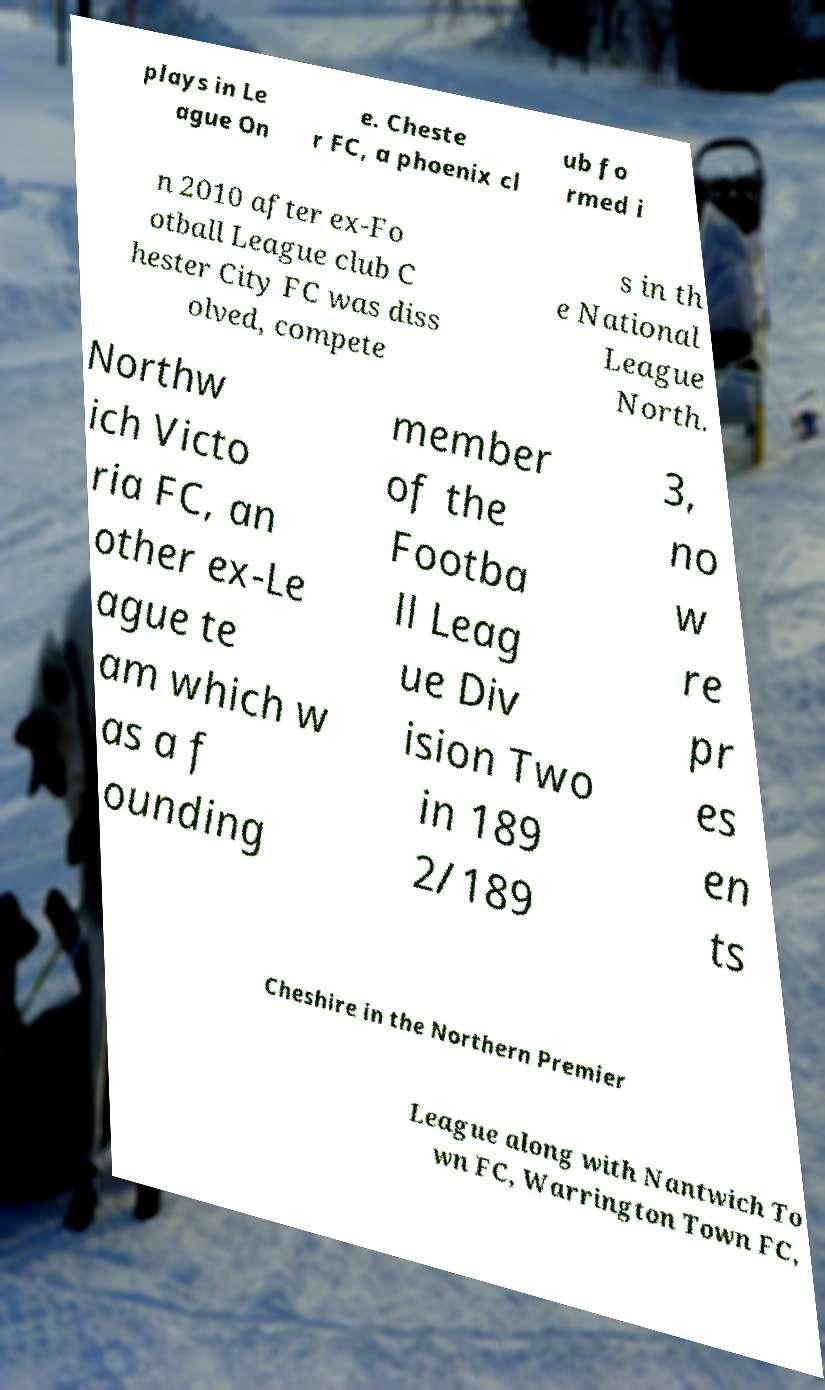For documentation purposes, I need the text within this image transcribed. Could you provide that? plays in Le ague On e. Cheste r FC, a phoenix cl ub fo rmed i n 2010 after ex-Fo otball League club C hester City FC was diss olved, compete s in th e National League North. Northw ich Victo ria FC, an other ex-Le ague te am which w as a f ounding member of the Footba ll Leag ue Div ision Two in 189 2/189 3, no w re pr es en ts Cheshire in the Northern Premier League along with Nantwich To wn FC, Warrington Town FC, 